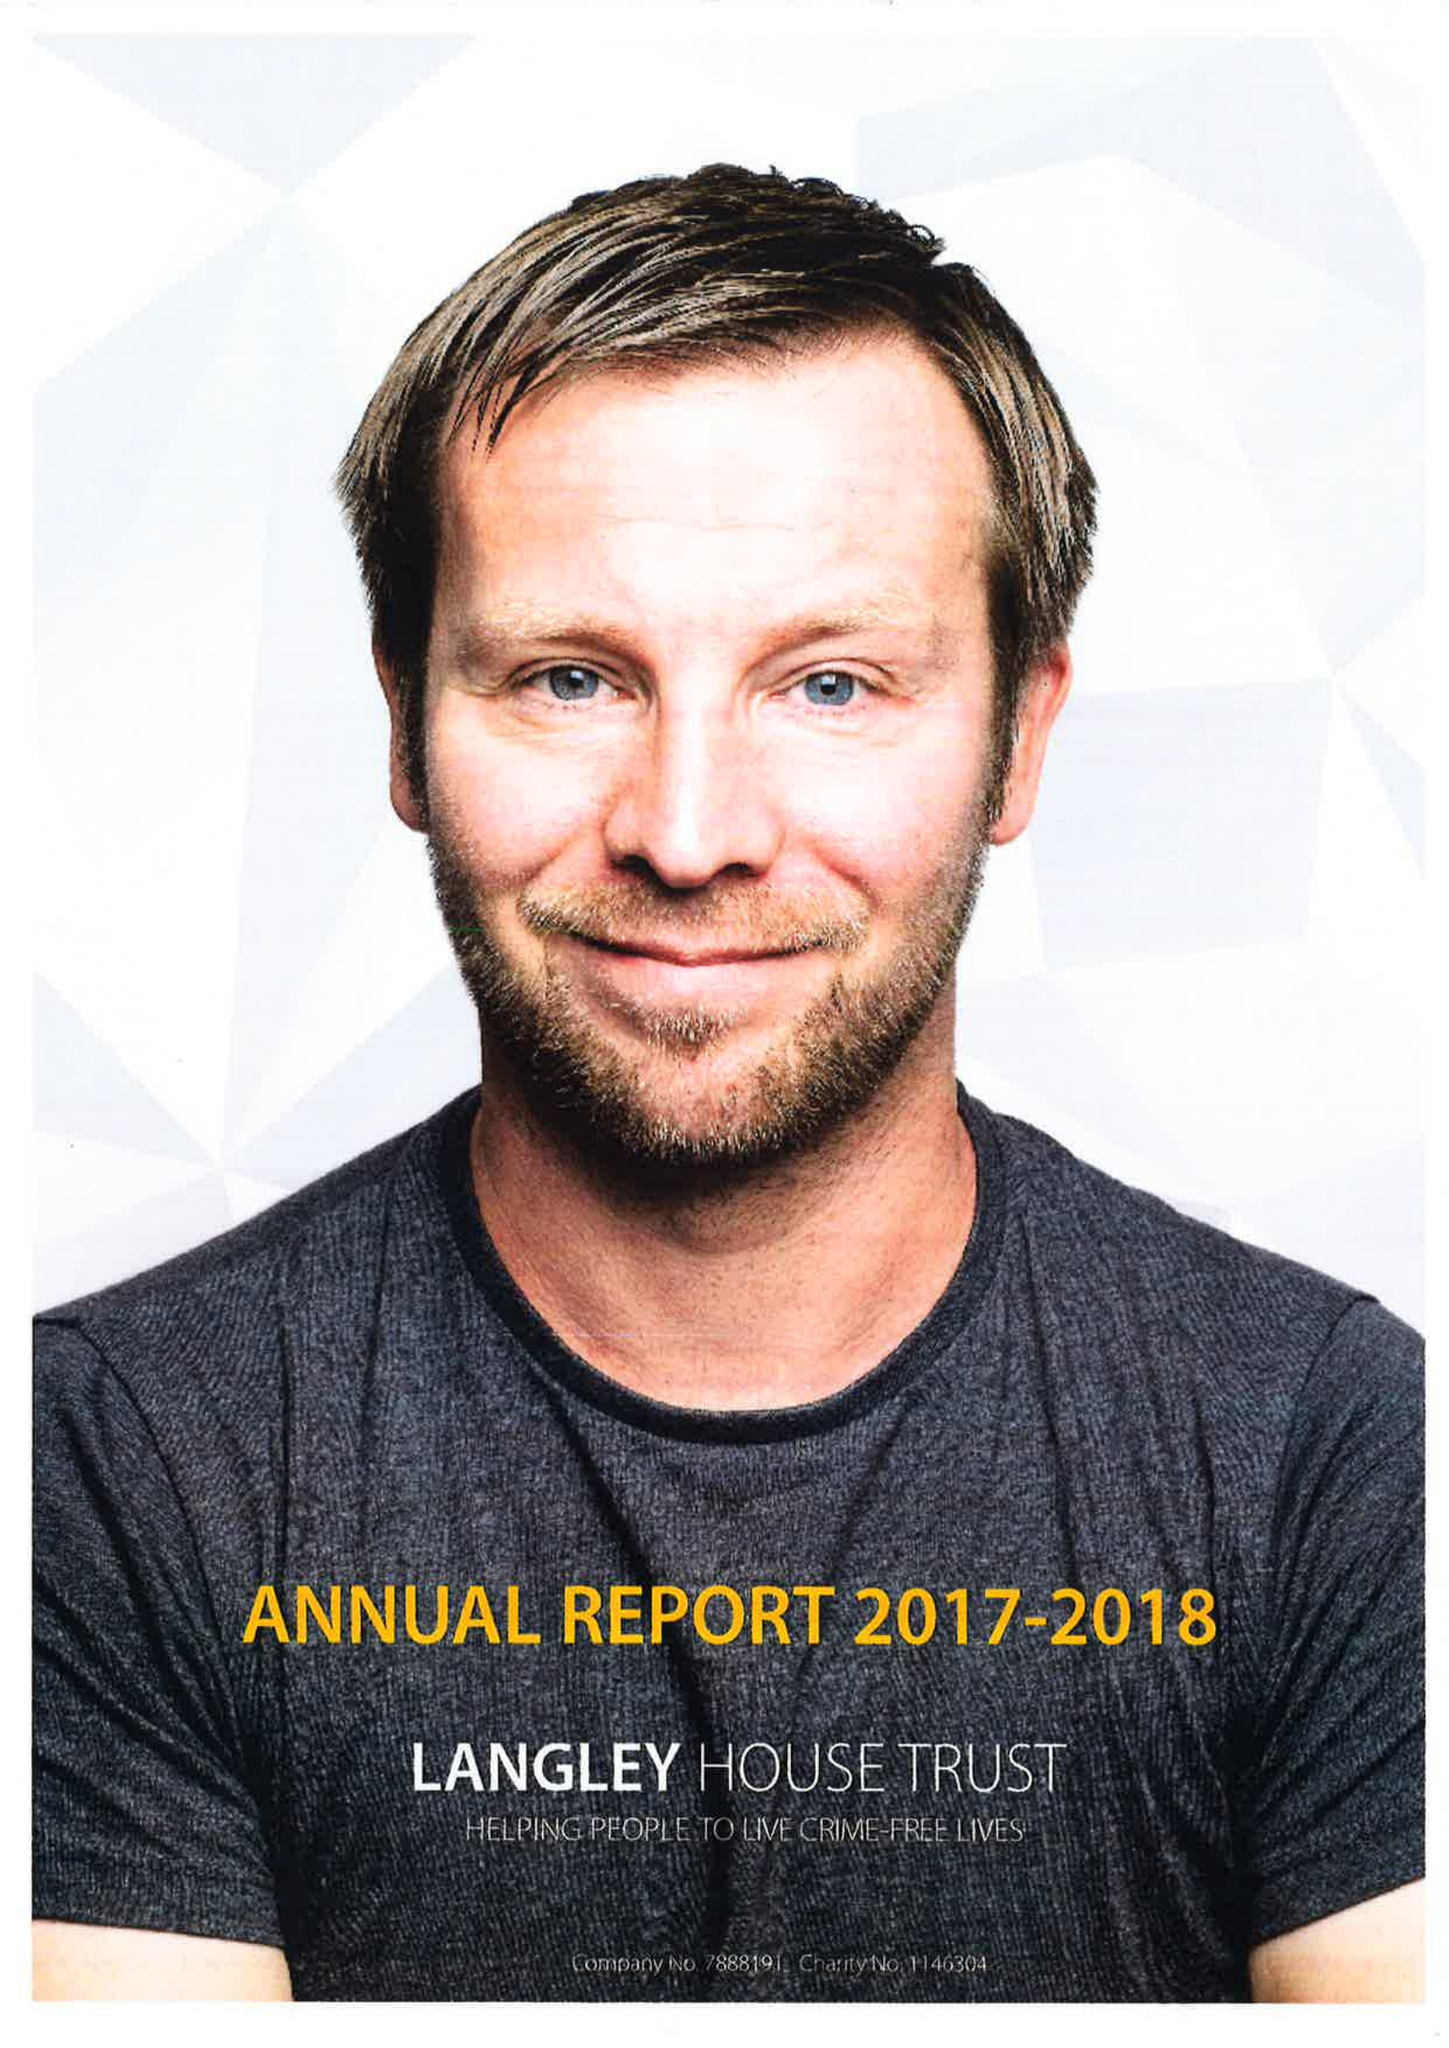What is the value for the income_annually_in_british_pounds?
Answer the question using a single word or phrase. 12411000.00 